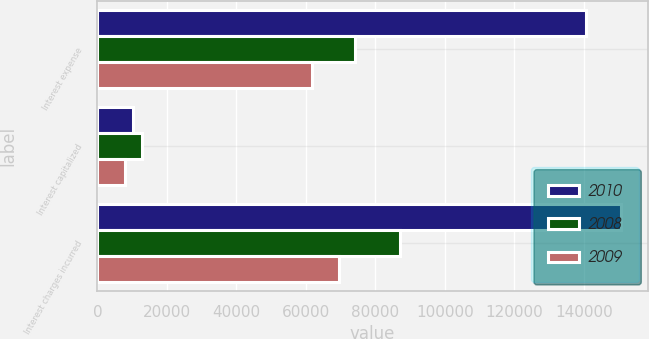<chart> <loc_0><loc_0><loc_500><loc_500><stacked_bar_chart><ecel><fcel>Interest expense<fcel>Interest capitalized<fcel>Interest charges incurred<nl><fcel>2010<fcel>140475<fcel>10349<fcel>150824<nl><fcel>2008<fcel>74232<fcel>12853<fcel>87085<nl><fcel>2009<fcel>61677<fcel>7946<fcel>69623<nl></chart> 